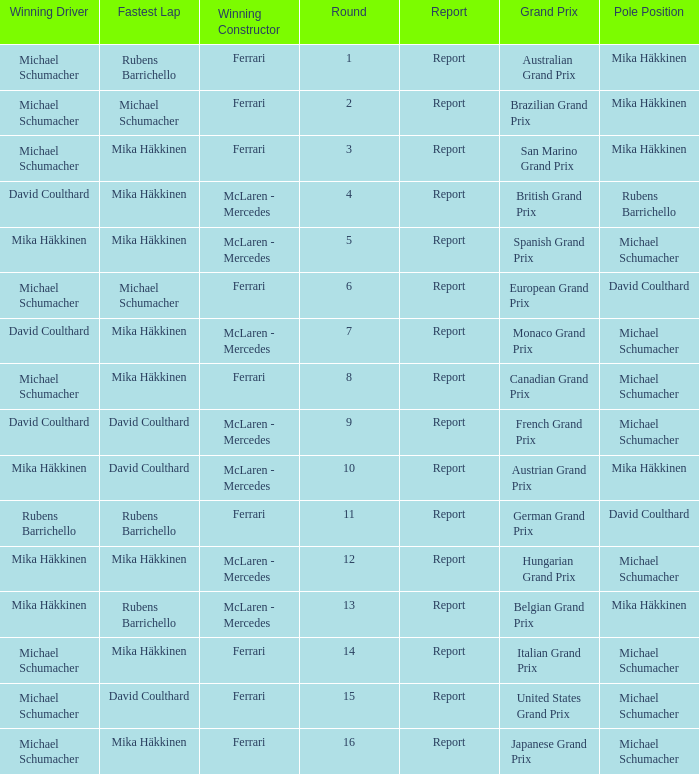How many drivers won the Italian Grand Prix? 1.0. 